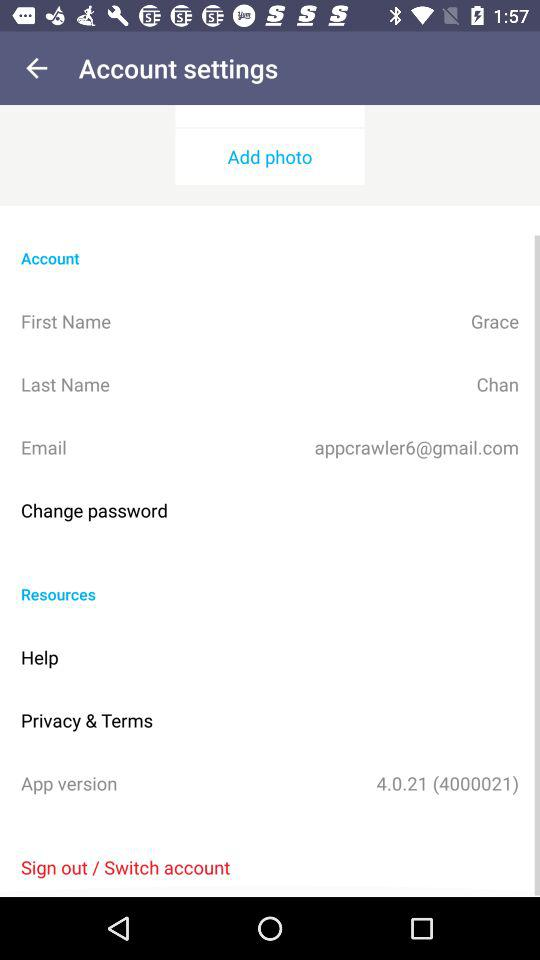What is the first name? The first name is Grace. 